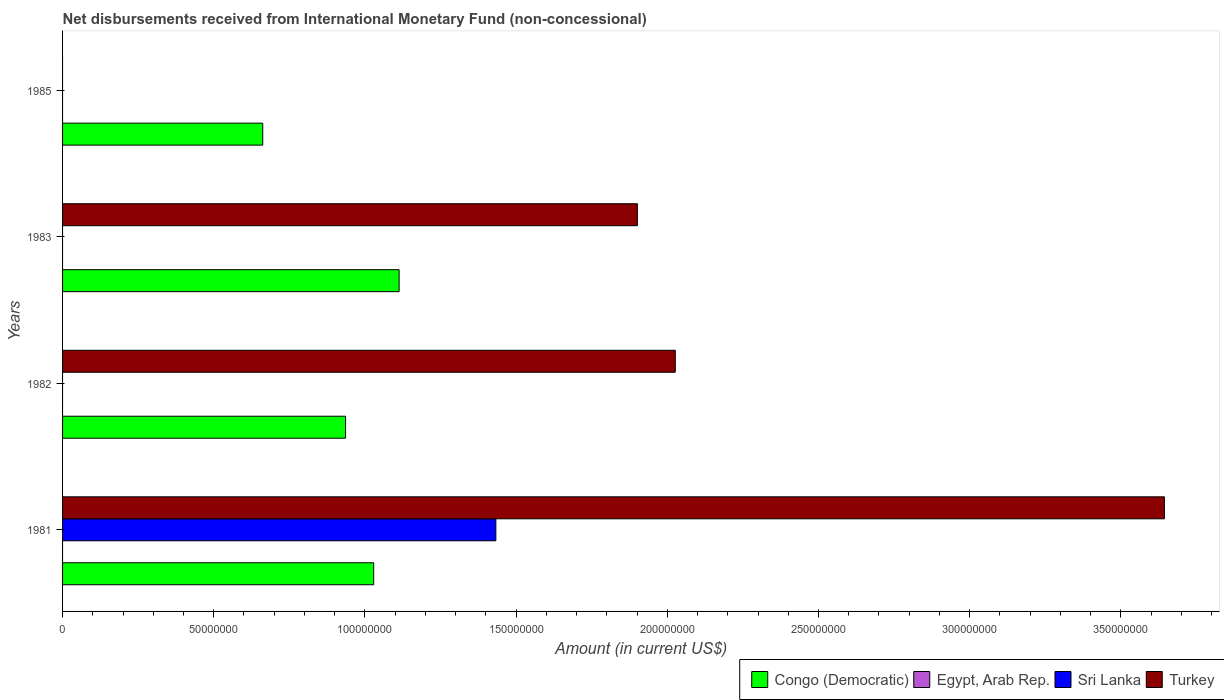Are the number of bars on each tick of the Y-axis equal?
Offer a terse response. No. What is the label of the 2nd group of bars from the top?
Make the answer very short. 1983. What is the amount of disbursements received from International Monetary Fund in Congo (Democratic) in 1982?
Your response must be concise. 9.36e+07. Across all years, what is the maximum amount of disbursements received from International Monetary Fund in Sri Lanka?
Make the answer very short. 1.43e+08. Across all years, what is the minimum amount of disbursements received from International Monetary Fund in Congo (Democratic)?
Your answer should be very brief. 6.62e+07. What is the total amount of disbursements received from International Monetary Fund in Sri Lanka in the graph?
Keep it short and to the point. 1.43e+08. What is the difference between the amount of disbursements received from International Monetary Fund in Turkey in 1981 and that in 1982?
Provide a short and direct response. 1.62e+08. What is the difference between the amount of disbursements received from International Monetary Fund in Turkey in 1981 and the amount of disbursements received from International Monetary Fund in Egypt, Arab Rep. in 1982?
Make the answer very short. 3.64e+08. What is the average amount of disbursements received from International Monetary Fund in Turkey per year?
Make the answer very short. 1.89e+08. What is the ratio of the amount of disbursements received from International Monetary Fund in Congo (Democratic) in 1982 to that in 1985?
Your response must be concise. 1.41. Is the amount of disbursements received from International Monetary Fund in Congo (Democratic) in 1982 less than that in 1985?
Offer a very short reply. No. What is the difference between the highest and the second highest amount of disbursements received from International Monetary Fund in Turkey?
Your answer should be compact. 1.62e+08. What is the difference between the highest and the lowest amount of disbursements received from International Monetary Fund in Congo (Democratic)?
Offer a terse response. 4.51e+07. In how many years, is the amount of disbursements received from International Monetary Fund in Congo (Democratic) greater than the average amount of disbursements received from International Monetary Fund in Congo (Democratic) taken over all years?
Make the answer very short. 3. Is the sum of the amount of disbursements received from International Monetary Fund in Congo (Democratic) in 1983 and 1985 greater than the maximum amount of disbursements received from International Monetary Fund in Egypt, Arab Rep. across all years?
Keep it short and to the point. Yes. Are all the bars in the graph horizontal?
Make the answer very short. Yes. How many years are there in the graph?
Offer a terse response. 4. What is the difference between two consecutive major ticks on the X-axis?
Your response must be concise. 5.00e+07. Does the graph contain any zero values?
Give a very brief answer. Yes. Does the graph contain grids?
Make the answer very short. No. Where does the legend appear in the graph?
Offer a terse response. Bottom right. How many legend labels are there?
Ensure brevity in your answer.  4. How are the legend labels stacked?
Offer a very short reply. Horizontal. What is the title of the graph?
Keep it short and to the point. Net disbursements received from International Monetary Fund (non-concessional). Does "United Arab Emirates" appear as one of the legend labels in the graph?
Your answer should be compact. No. What is the Amount (in current US$) of Congo (Democratic) in 1981?
Make the answer very short. 1.03e+08. What is the Amount (in current US$) of Egypt, Arab Rep. in 1981?
Offer a very short reply. 0. What is the Amount (in current US$) in Sri Lanka in 1981?
Provide a short and direct response. 1.43e+08. What is the Amount (in current US$) in Turkey in 1981?
Your answer should be very brief. 3.64e+08. What is the Amount (in current US$) in Congo (Democratic) in 1982?
Keep it short and to the point. 9.36e+07. What is the Amount (in current US$) of Turkey in 1982?
Give a very brief answer. 2.03e+08. What is the Amount (in current US$) of Congo (Democratic) in 1983?
Make the answer very short. 1.11e+08. What is the Amount (in current US$) of Sri Lanka in 1983?
Ensure brevity in your answer.  0. What is the Amount (in current US$) in Turkey in 1983?
Your answer should be compact. 1.90e+08. What is the Amount (in current US$) of Congo (Democratic) in 1985?
Your answer should be compact. 6.62e+07. What is the Amount (in current US$) of Egypt, Arab Rep. in 1985?
Your answer should be very brief. 0. What is the Amount (in current US$) in Sri Lanka in 1985?
Offer a terse response. 0. What is the Amount (in current US$) in Turkey in 1985?
Your answer should be very brief. 0. Across all years, what is the maximum Amount (in current US$) in Congo (Democratic)?
Keep it short and to the point. 1.11e+08. Across all years, what is the maximum Amount (in current US$) of Sri Lanka?
Keep it short and to the point. 1.43e+08. Across all years, what is the maximum Amount (in current US$) in Turkey?
Provide a short and direct response. 3.64e+08. Across all years, what is the minimum Amount (in current US$) of Congo (Democratic)?
Provide a short and direct response. 6.62e+07. Across all years, what is the minimum Amount (in current US$) in Sri Lanka?
Offer a terse response. 0. Across all years, what is the minimum Amount (in current US$) in Turkey?
Your answer should be very brief. 0. What is the total Amount (in current US$) of Congo (Democratic) in the graph?
Offer a very short reply. 3.74e+08. What is the total Amount (in current US$) of Egypt, Arab Rep. in the graph?
Offer a very short reply. 0. What is the total Amount (in current US$) of Sri Lanka in the graph?
Offer a terse response. 1.43e+08. What is the total Amount (in current US$) in Turkey in the graph?
Provide a short and direct response. 7.57e+08. What is the difference between the Amount (in current US$) in Congo (Democratic) in 1981 and that in 1982?
Provide a succinct answer. 9.30e+06. What is the difference between the Amount (in current US$) of Turkey in 1981 and that in 1982?
Your answer should be very brief. 1.62e+08. What is the difference between the Amount (in current US$) of Congo (Democratic) in 1981 and that in 1983?
Provide a succinct answer. -8.40e+06. What is the difference between the Amount (in current US$) of Turkey in 1981 and that in 1983?
Ensure brevity in your answer.  1.74e+08. What is the difference between the Amount (in current US$) of Congo (Democratic) in 1981 and that in 1985?
Give a very brief answer. 3.67e+07. What is the difference between the Amount (in current US$) of Congo (Democratic) in 1982 and that in 1983?
Provide a succinct answer. -1.77e+07. What is the difference between the Amount (in current US$) in Turkey in 1982 and that in 1983?
Provide a succinct answer. 1.25e+07. What is the difference between the Amount (in current US$) in Congo (Democratic) in 1982 and that in 1985?
Your answer should be very brief. 2.74e+07. What is the difference between the Amount (in current US$) in Congo (Democratic) in 1983 and that in 1985?
Provide a short and direct response. 4.51e+07. What is the difference between the Amount (in current US$) of Congo (Democratic) in 1981 and the Amount (in current US$) of Turkey in 1982?
Your answer should be compact. -9.97e+07. What is the difference between the Amount (in current US$) in Sri Lanka in 1981 and the Amount (in current US$) in Turkey in 1982?
Your answer should be compact. -5.93e+07. What is the difference between the Amount (in current US$) of Congo (Democratic) in 1981 and the Amount (in current US$) of Turkey in 1983?
Offer a very short reply. -8.72e+07. What is the difference between the Amount (in current US$) in Sri Lanka in 1981 and the Amount (in current US$) in Turkey in 1983?
Offer a terse response. -4.68e+07. What is the difference between the Amount (in current US$) of Congo (Democratic) in 1982 and the Amount (in current US$) of Turkey in 1983?
Ensure brevity in your answer.  -9.65e+07. What is the average Amount (in current US$) of Congo (Democratic) per year?
Provide a short and direct response. 9.35e+07. What is the average Amount (in current US$) of Egypt, Arab Rep. per year?
Your answer should be very brief. 0. What is the average Amount (in current US$) of Sri Lanka per year?
Ensure brevity in your answer.  3.58e+07. What is the average Amount (in current US$) of Turkey per year?
Make the answer very short. 1.89e+08. In the year 1981, what is the difference between the Amount (in current US$) in Congo (Democratic) and Amount (in current US$) in Sri Lanka?
Your answer should be very brief. -4.04e+07. In the year 1981, what is the difference between the Amount (in current US$) of Congo (Democratic) and Amount (in current US$) of Turkey?
Offer a very short reply. -2.62e+08. In the year 1981, what is the difference between the Amount (in current US$) of Sri Lanka and Amount (in current US$) of Turkey?
Offer a very short reply. -2.21e+08. In the year 1982, what is the difference between the Amount (in current US$) in Congo (Democratic) and Amount (in current US$) in Turkey?
Ensure brevity in your answer.  -1.09e+08. In the year 1983, what is the difference between the Amount (in current US$) in Congo (Democratic) and Amount (in current US$) in Turkey?
Keep it short and to the point. -7.88e+07. What is the ratio of the Amount (in current US$) in Congo (Democratic) in 1981 to that in 1982?
Ensure brevity in your answer.  1.1. What is the ratio of the Amount (in current US$) in Turkey in 1981 to that in 1982?
Give a very brief answer. 1.8. What is the ratio of the Amount (in current US$) in Congo (Democratic) in 1981 to that in 1983?
Keep it short and to the point. 0.92. What is the ratio of the Amount (in current US$) in Turkey in 1981 to that in 1983?
Offer a very short reply. 1.92. What is the ratio of the Amount (in current US$) in Congo (Democratic) in 1981 to that in 1985?
Ensure brevity in your answer.  1.55. What is the ratio of the Amount (in current US$) of Congo (Democratic) in 1982 to that in 1983?
Provide a short and direct response. 0.84. What is the ratio of the Amount (in current US$) of Turkey in 1982 to that in 1983?
Your answer should be compact. 1.07. What is the ratio of the Amount (in current US$) in Congo (Democratic) in 1982 to that in 1985?
Provide a succinct answer. 1.41. What is the ratio of the Amount (in current US$) of Congo (Democratic) in 1983 to that in 1985?
Your response must be concise. 1.68. What is the difference between the highest and the second highest Amount (in current US$) in Congo (Democratic)?
Your response must be concise. 8.40e+06. What is the difference between the highest and the second highest Amount (in current US$) of Turkey?
Provide a short and direct response. 1.62e+08. What is the difference between the highest and the lowest Amount (in current US$) of Congo (Democratic)?
Provide a short and direct response. 4.51e+07. What is the difference between the highest and the lowest Amount (in current US$) of Sri Lanka?
Keep it short and to the point. 1.43e+08. What is the difference between the highest and the lowest Amount (in current US$) of Turkey?
Give a very brief answer. 3.64e+08. 